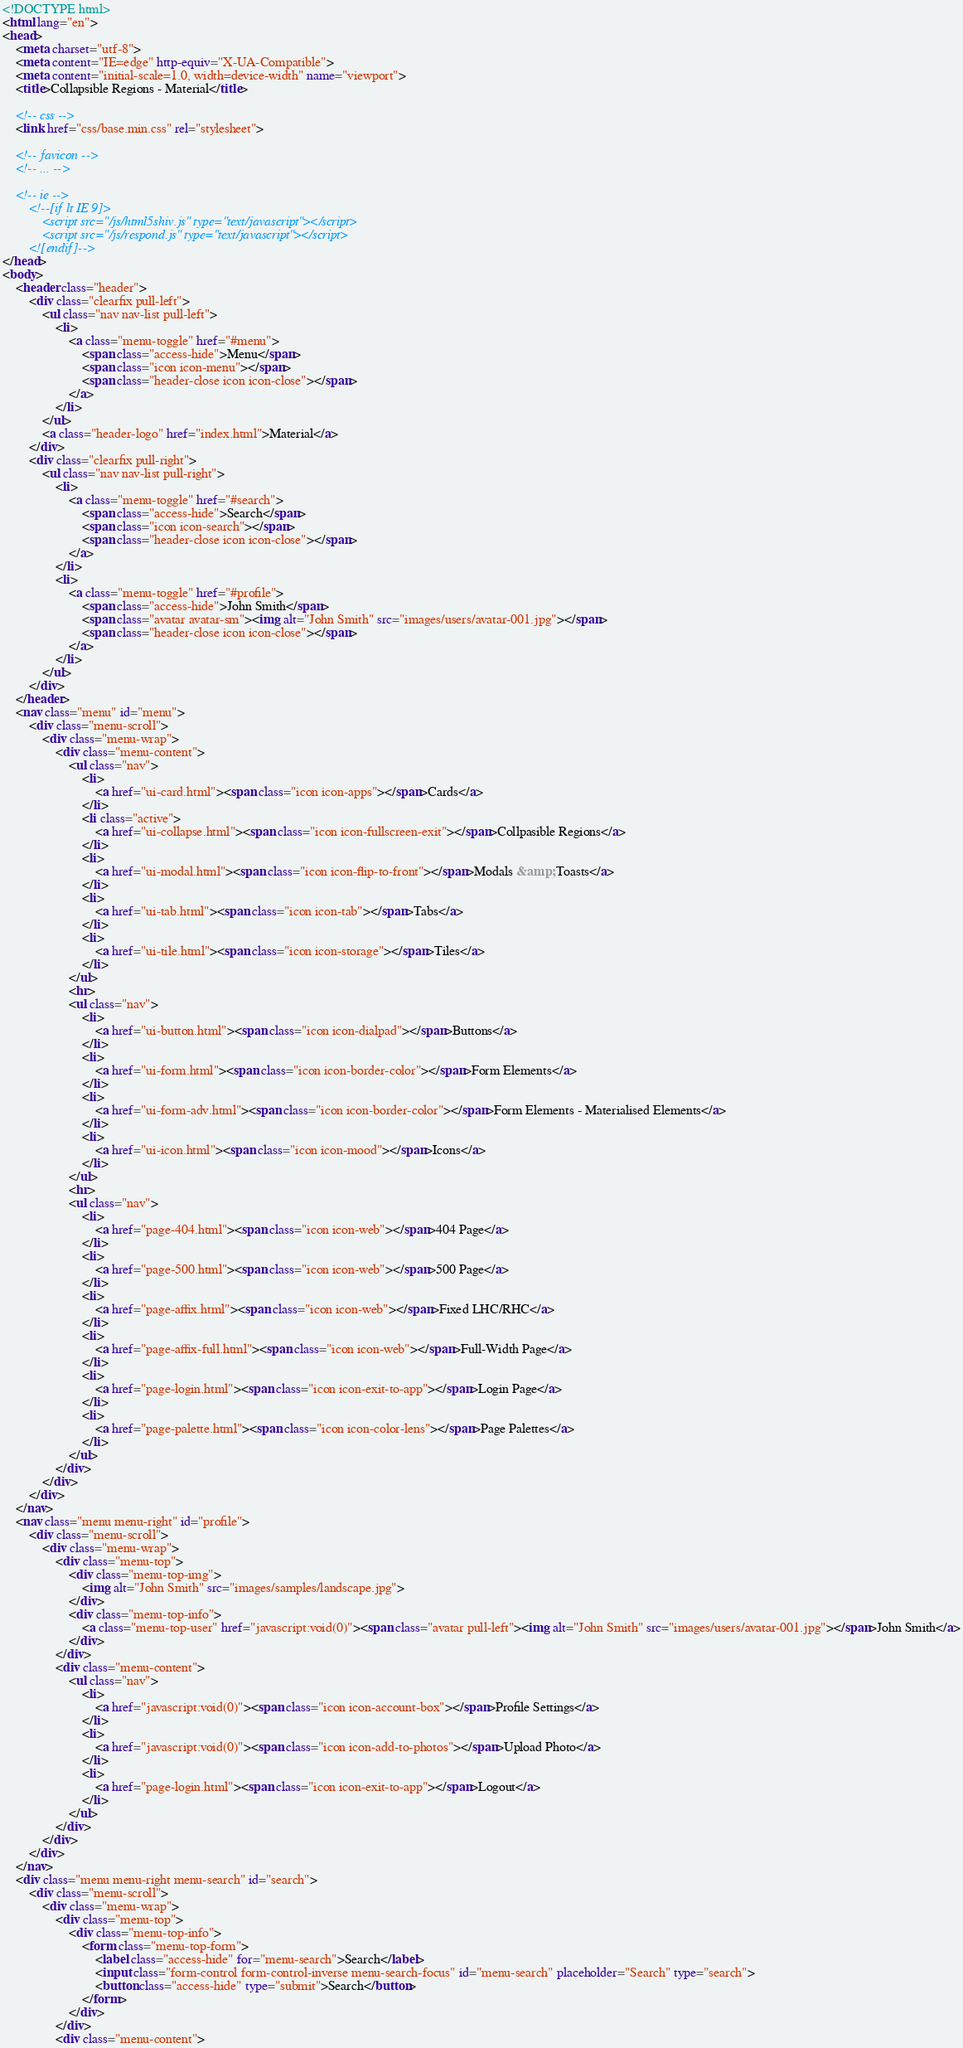Convert code to text. <code><loc_0><loc_0><loc_500><loc_500><_HTML_><!DOCTYPE html>
<html lang="en">
<head>
	<meta charset="utf-8">
	<meta content="IE=edge" http-equiv="X-UA-Compatible">
	<meta content="initial-scale=1.0, width=device-width" name="viewport">
	<title>Collapsible Regions - Material</title>

	<!-- css -->
	<link href="css/base.min.css" rel="stylesheet">

	<!-- favicon -->
	<!-- ... -->

	<!-- ie -->
		<!--[if lt IE 9]>
			<script src="/js/html5shiv.js" type="text/javascript"></script>
			<script src="/js/respond.js" type="text/javascript"></script>
		<![endif]-->
</head>
<body>
	<header class="header">
		<div class="clearfix pull-left">
			<ul class="nav nav-list pull-left">
				<li>
					<a class="menu-toggle" href="#menu">
						<span class="access-hide">Menu</span>
						<span class="icon icon-menu"></span>
						<span class="header-close icon icon-close"></span>
					</a>
				</li>
			</ul>
			<a class="header-logo" href="index.html">Material</a>
		</div>
		<div class="clearfix pull-right">
			<ul class="nav nav-list pull-right">
				<li>
					<a class="menu-toggle" href="#search">
						<span class="access-hide">Search</span>
						<span class="icon icon-search"></span>
						<span class="header-close icon icon-close"></span>
					</a>
				</li>
				<li>
					<a class="menu-toggle" href="#profile">
						<span class="access-hide">John Smith</span>
						<span class="avatar avatar-sm"><img alt="John Smith" src="images/users/avatar-001.jpg"></span>
						<span class="header-close icon icon-close"></span>
					</a>
				</li>
			</ul>
		</div>
	</header>
	<nav class="menu" id="menu">
		<div class="menu-scroll">
			<div class="menu-wrap">
				<div class="menu-content">
					<ul class="nav">
						<li>
							<a href="ui-card.html"><span class="icon icon-apps"></span>Cards</a>
						</li>
						<li class="active">
							<a href="ui-collapse.html"><span class="icon icon-fullscreen-exit"></span>Collpasible Regions</a>
						</li>
						<li>
							<a href="ui-modal.html"><span class="icon icon-flip-to-front"></span>Modals &amp; Toasts</a>
						</li>
						<li>
							<a href="ui-tab.html"><span class="icon icon-tab"></span>Tabs</a>
						</li>
						<li>
							<a href="ui-tile.html"><span class="icon icon-storage"></span>Tiles</a>
						</li>
					</ul>
					<hr>
					<ul class="nav">
						<li>
							<a href="ui-button.html"><span class="icon icon-dialpad"></span>Buttons</a>
						</li>
						<li>
							<a href="ui-form.html"><span class="icon icon-border-color"></span>Form Elements</a>
						</li>
						<li>
							<a href="ui-form-adv.html"><span class="icon icon-border-color"></span>Form Elements - Materialised Elements</a>
						</li>
						<li>
							<a href="ui-icon.html"><span class="icon icon-mood"></span>Icons</a>
						</li>
					</ul>
					<hr>
					<ul class="nav">
						<li>
							<a href="page-404.html"><span class="icon icon-web"></span>404 Page</a>
						</li>
						<li>
							<a href="page-500.html"><span class="icon icon-web"></span>500 Page</a>
						</li>
						<li>
							<a href="page-affix.html"><span class="icon icon-web"></span>Fixed LHC/RHC</a>
						</li>
						<li>
							<a href="page-affix-full.html"><span class="icon icon-web"></span>Full-Width Page</a>
						</li>
						<li>
							<a href="page-login.html"><span class="icon icon-exit-to-app"></span>Login Page</a>
						</li>
						<li>
							<a href="page-palette.html"><span class="icon icon-color-lens"></span>Page Palettes</a>
						</li>
					</ul>
				</div>
			</div>
		</div>
	</nav>
	<nav class="menu menu-right" id="profile">
		<div class="menu-scroll">
			<div class="menu-wrap">
				<div class="menu-top">
					<div class="menu-top-img">
						<img alt="John Smith" src="images/samples/landscape.jpg">
					</div>
					<div class="menu-top-info">
						<a class="menu-top-user" href="javascript:void(0)"><span class="avatar pull-left"><img alt="John Smith" src="images/users/avatar-001.jpg"></span>John Smith</a>
					</div>
				</div>
				<div class="menu-content">
					<ul class="nav">
						<li>
							<a href="javascript:void(0)"><span class="icon icon-account-box"></span>Profile Settings</a>
						</li>
						<li>
							<a href="javascript:void(0)"><span class="icon icon-add-to-photos"></span>Upload Photo</a>
						</li>
						<li>
							<a href="page-login.html"><span class="icon icon-exit-to-app"></span>Logout</a>
						</li>
					</ul>
				</div>
			</div>
		</div>
	</nav>
	<div class="menu menu-right menu-search" id="search">
		<div class="menu-scroll">
			<div class="menu-wrap">
				<div class="menu-top">
					<div class="menu-top-info">
						<form class="menu-top-form">
							<label class="access-hide" for="menu-search">Search</label>
							<input class="form-control form-control-inverse menu-search-focus" id="menu-search" placeholder="Search" type="search">
							<button class="access-hide" type="submit">Search</button>
						</form>
					</div>
				</div>
				<div class="menu-content"></code> 